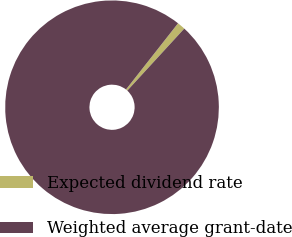Convert chart. <chart><loc_0><loc_0><loc_500><loc_500><pie_chart><fcel>Expected dividend rate<fcel>Weighted average grant-date<nl><fcel>1.22%<fcel>98.78%<nl></chart> 